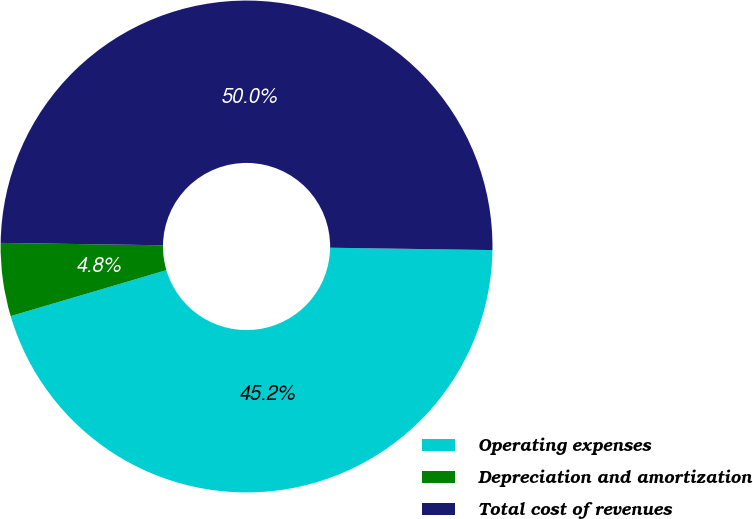Convert chart. <chart><loc_0><loc_0><loc_500><loc_500><pie_chart><fcel>Operating expenses<fcel>Depreciation and amortization<fcel>Total cost of revenues<nl><fcel>45.2%<fcel>4.8%<fcel>50.0%<nl></chart> 